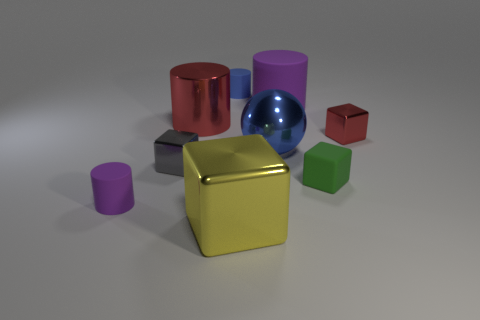What is the green block made of?
Your answer should be compact. Rubber. There is a thing that is the same color as the shiny sphere; what is its size?
Your response must be concise. Small. Do the small purple rubber thing and the small metallic thing right of the tiny green object have the same shape?
Give a very brief answer. No. What material is the large cylinder that is on the right side of the small matte cylinder that is to the right of the purple cylinder left of the blue cylinder?
Ensure brevity in your answer.  Rubber. What number of small metallic objects are there?
Offer a terse response. 2. What number of blue objects are either big shiny objects or metal things?
Your response must be concise. 1. How many other things are the same shape as the big blue thing?
Keep it short and to the point. 0. There is a block in front of the green rubber thing; is it the same color as the large shiny object to the left of the yellow metallic object?
Offer a very short reply. No. What number of small things are either red metal cubes or red cylinders?
Keep it short and to the point. 1. What is the size of the red object that is the same shape as the tiny gray metal thing?
Give a very brief answer. Small. 